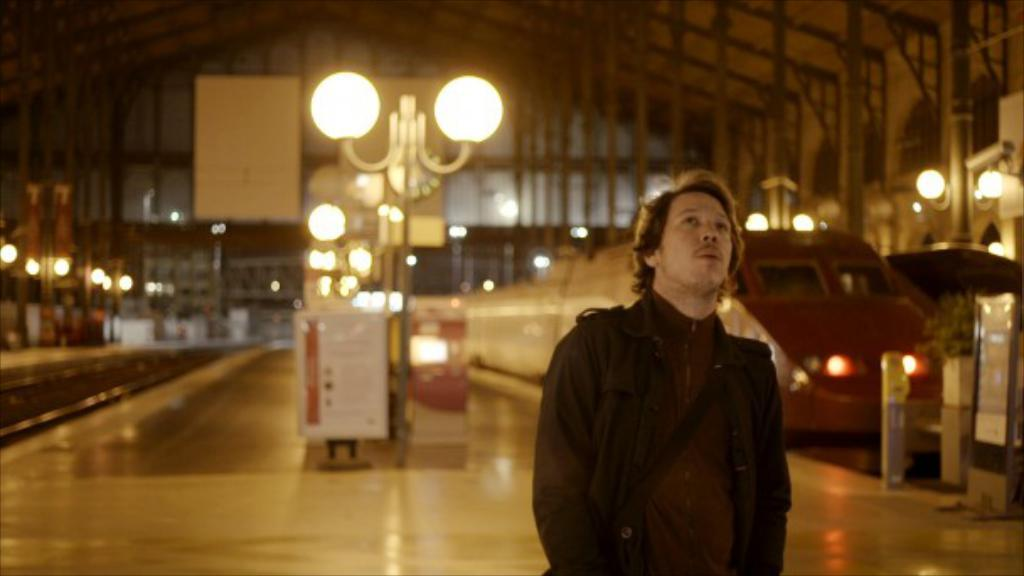Who is present in the image? There is a person in the image. What is the person wearing? The person is wearing a black jacket. What is the person's posture in the image? The person is standing. What type of transportation can be seen in the image? There is a train in the image. What can be seen illuminated in the image? There are lights visible in the image. What is the train situated on in the image? There are tracks in the image. What type of joke is being told by the person in the image? There is no indication of a joke being told in the image. 